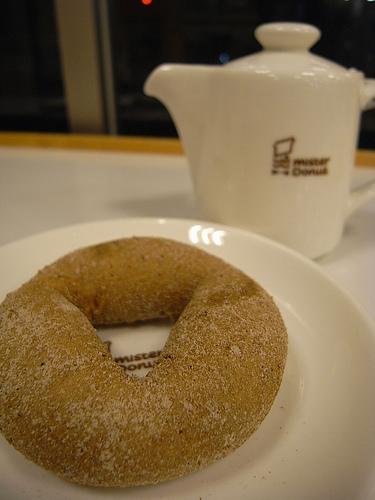Is this a bagel?
Concise answer only. Yes. How many calories does the bagel have?
Concise answer only. 500. What color plate is it on?
Concise answer only. White. 